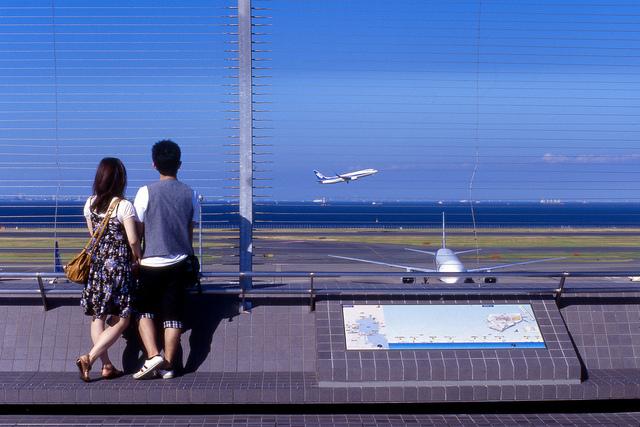Is a plane in the air?
Keep it brief. Yes. Are there people watching the planes?
Answer briefly. Yes. Are all jets in this photo facing the same direction?
Short answer required. No. 